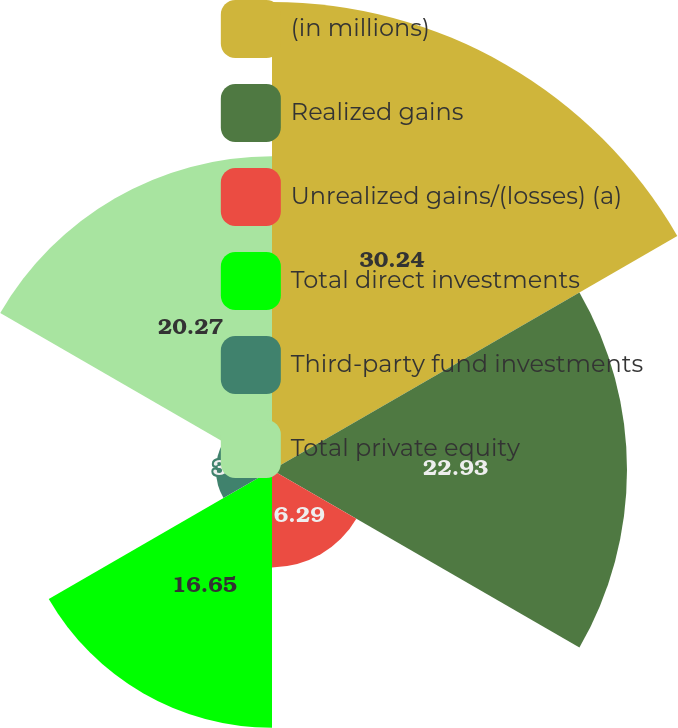Convert chart. <chart><loc_0><loc_0><loc_500><loc_500><pie_chart><fcel>(in millions)<fcel>Realized gains<fcel>Unrealized gains/(losses) (a)<fcel>Total direct investments<fcel>Third-party fund investments<fcel>Total private equity<nl><fcel>30.23%<fcel>22.93%<fcel>6.29%<fcel>16.65%<fcel>3.62%<fcel>20.27%<nl></chart> 